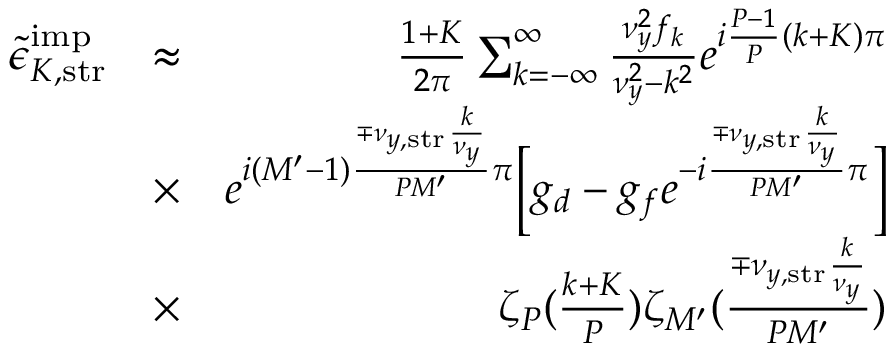<formula> <loc_0><loc_0><loc_500><loc_500>\begin{array} { r l r } { \tilde { \epsilon } _ { K , s t r } ^ { i m p } } & { \approx } & { \frac { 1 + K } { 2 \pi } \sum _ { k = - \infty } ^ { \infty } \frac { \nu _ { y } ^ { 2 } f _ { k } } { \nu _ { y } ^ { 2 } - k ^ { 2 } } e ^ { i \frac { P - 1 } { P } ( k + K ) \pi } } \\ & { \times } & { e ^ { i ( M ^ { \prime } - 1 ) \frac { \mp \nu _ { y , s t r } \frac { k } { \nu _ { y } } } { P M ^ { \prime } } \pi } \left [ g _ { d } - g _ { f } e ^ { - i \frac { \mp \nu _ { y , s t r } \frac { k } { \nu _ { y } } } { P M ^ { \prime } } \pi } \right ] } \\ & { \times } & { \zeta _ { P } ( \frac { k + K } { P } ) \zeta _ { M ^ { \prime } } ( \frac { \mp \nu _ { y , s t r } \frac { k } { \nu _ { y } } } { P M ^ { \prime } } ) } \end{array}</formula> 